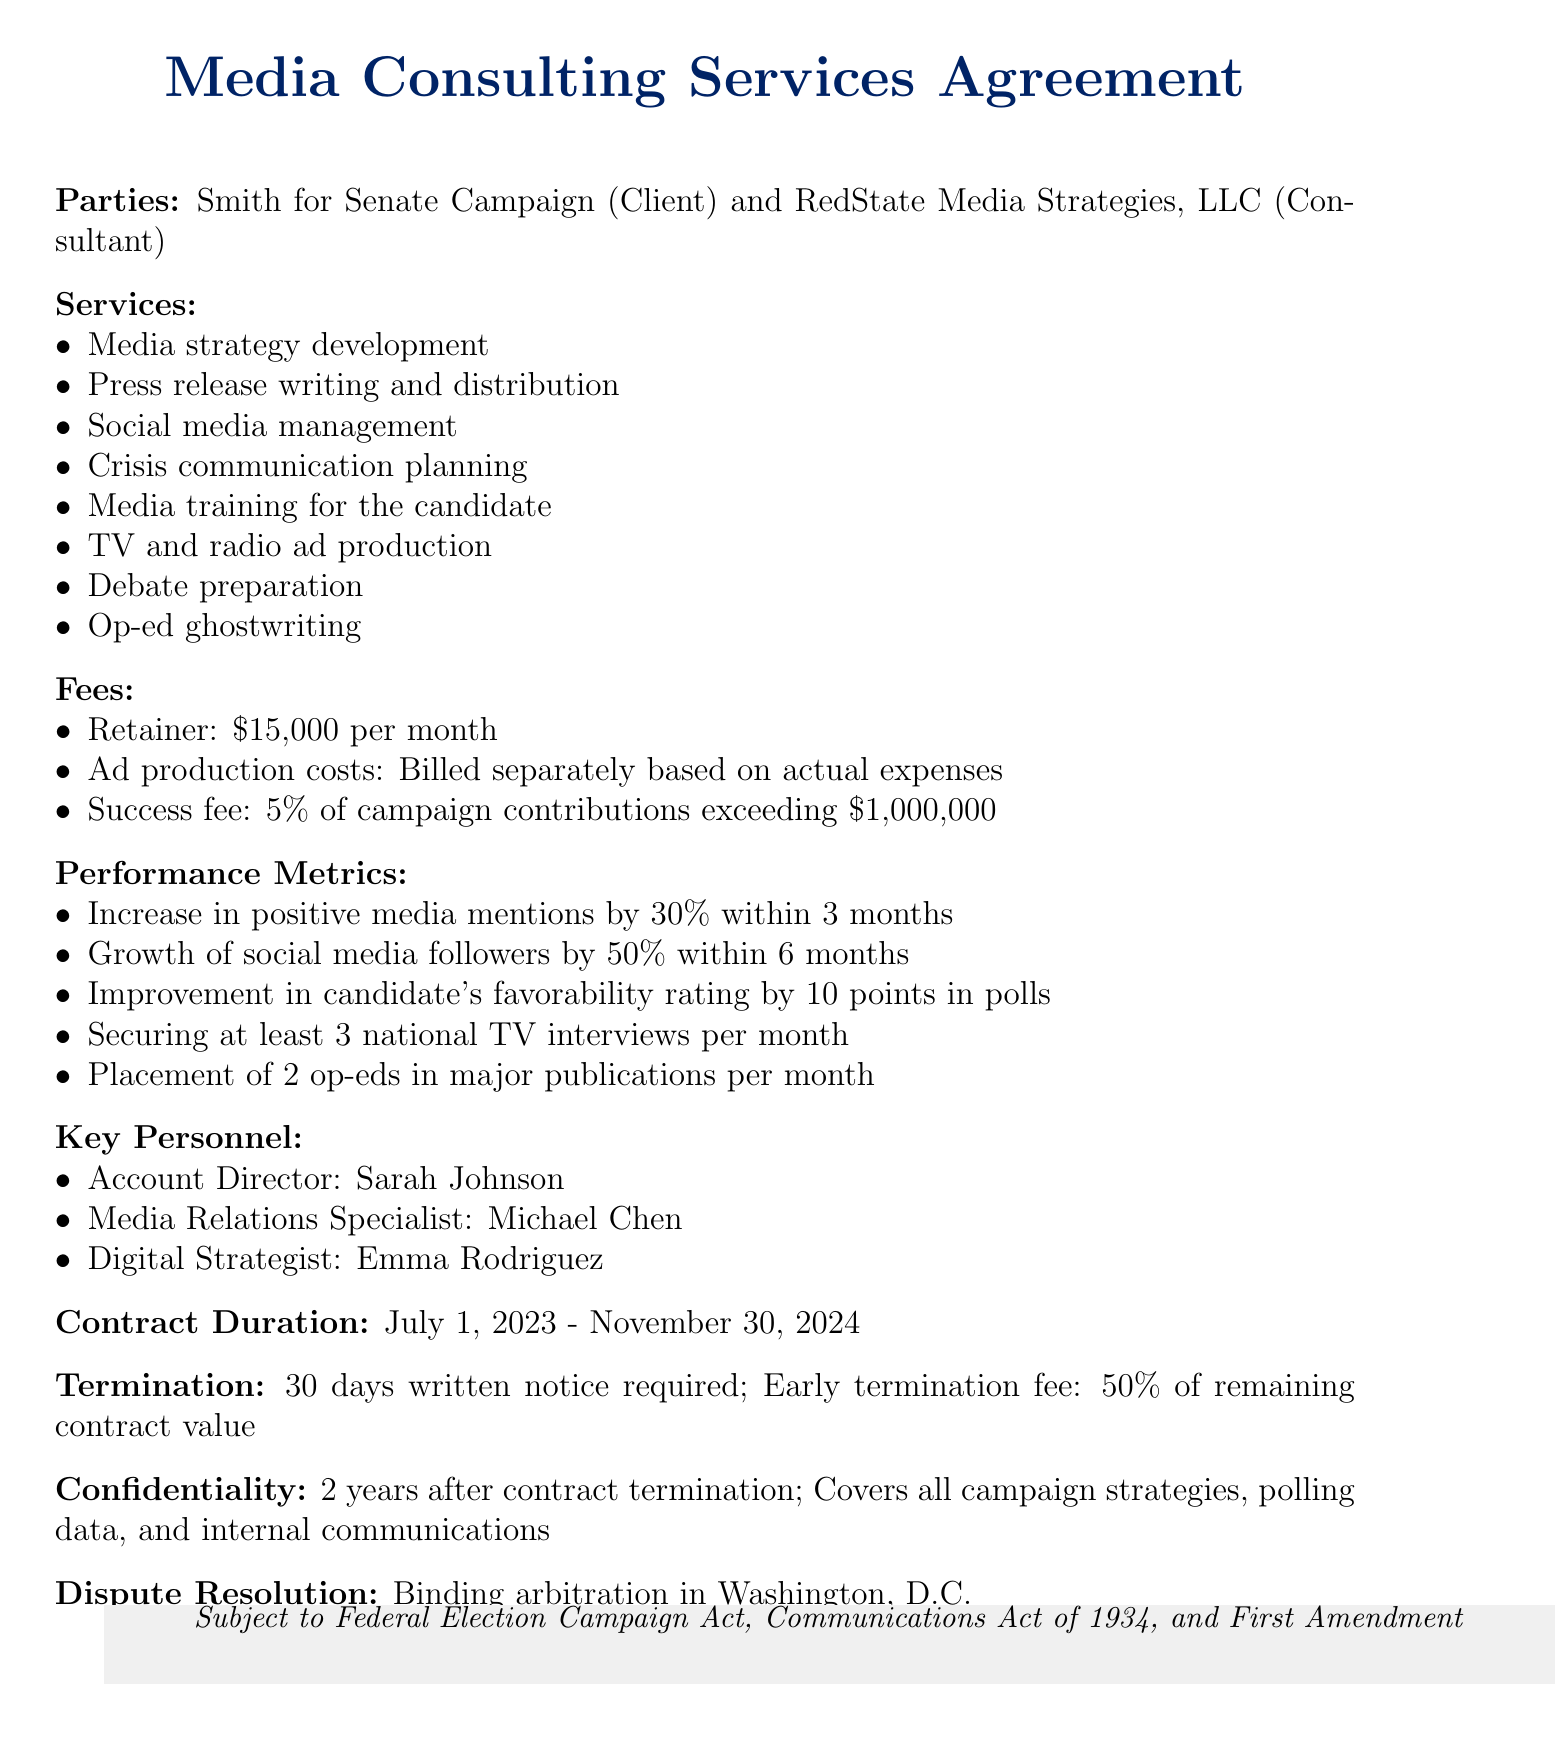What is the title of the document? The title of the document is stated clearly at the beginning of the rendered document.
Answer: Media Consulting Services Agreement Who are the parties involved in the contract? The document specifies the client and consultant involved in the agreement.
Answer: Smith for Senate Campaign and RedState Media Strategies, LLC What is the retainer fee per month? The monthly retainer fee is explicitly mentioned in the fees section of the document.
Answer: $15,000 per month How much is the success fee for the consulting firm? The success fee percentage is stated directly under the fees section.
Answer: 5% of campaign contributions exceeding $1,000,000 What is one of the performance metrics to be achieved? The performance metrics outline specific targets to be reached during the contract.
Answer: Increase in positive media mentions by 30% within 3 months When does the contract begin and end? The duration of the contract is mentioned with specific start and end dates.
Answer: July 1, 2023 - November 30, 2024 What is the termination notice period required? The termination notice period is specified in the termination section of the document.
Answer: 30 days written notice How long does the confidentiality clause last? The duration of the confidentiality obligation is specified in the confidentiality section.
Answer: 2 years after contract termination What is the dispute resolution method indicated? The method for resolving disputes is clearly stated in the dispute resolution section.
Answer: Binding arbitration 